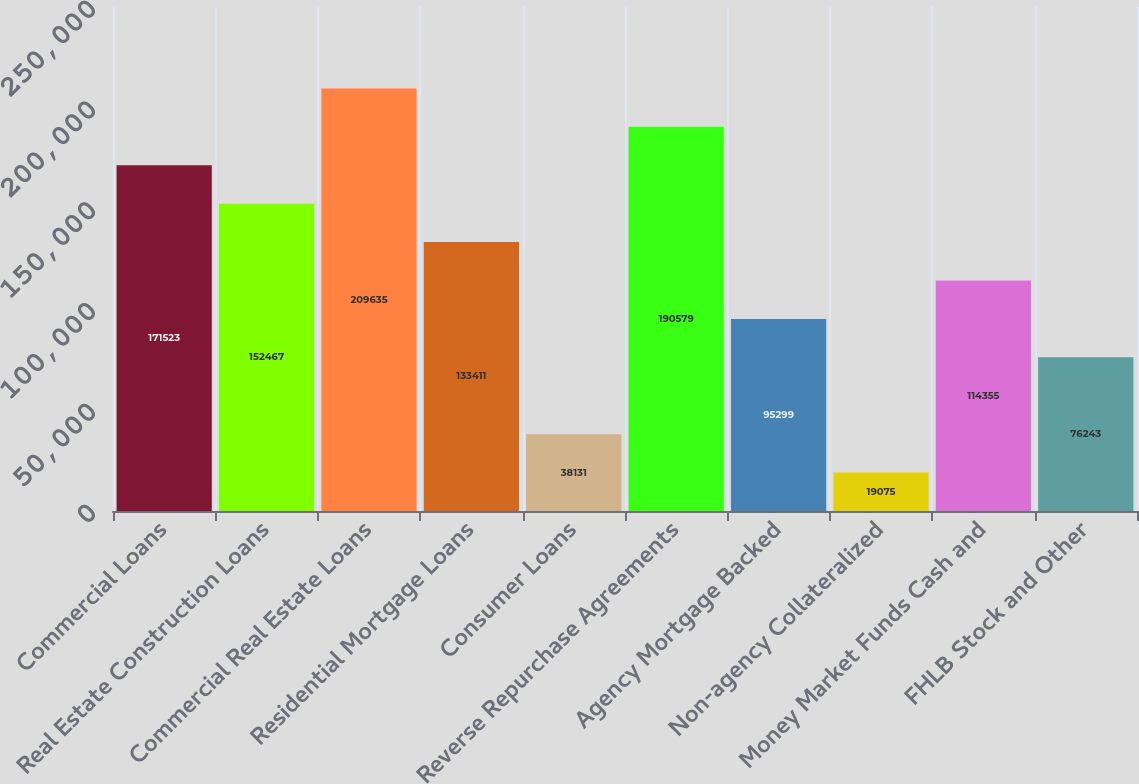<chart> <loc_0><loc_0><loc_500><loc_500><bar_chart><fcel>Commercial Loans<fcel>Real Estate Construction Loans<fcel>Commercial Real Estate Loans<fcel>Residential Mortgage Loans<fcel>Consumer Loans<fcel>Reverse Repurchase Agreements<fcel>Agency Mortgage Backed<fcel>Non-agency Collateralized<fcel>Money Market Funds Cash and<fcel>FHLB Stock and Other<nl><fcel>171523<fcel>152467<fcel>209635<fcel>133411<fcel>38131<fcel>190579<fcel>95299<fcel>19075<fcel>114355<fcel>76243<nl></chart> 